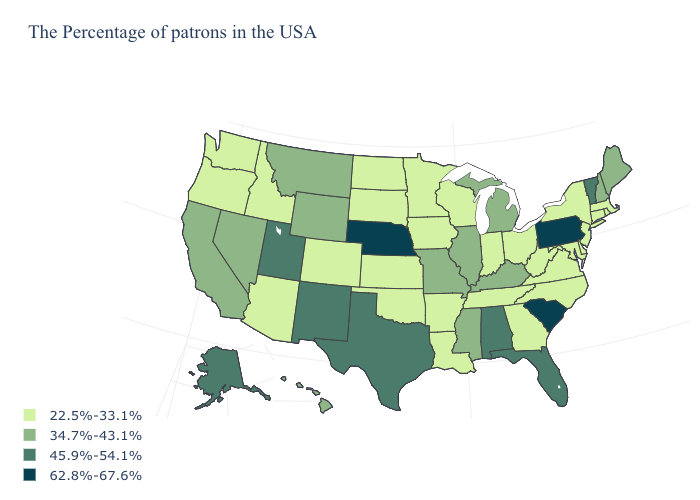Does Vermont have a higher value than Florida?
Keep it brief. No. Name the states that have a value in the range 22.5%-33.1%?
Keep it brief. Massachusetts, Rhode Island, Connecticut, New York, New Jersey, Delaware, Maryland, Virginia, North Carolina, West Virginia, Ohio, Georgia, Indiana, Tennessee, Wisconsin, Louisiana, Arkansas, Minnesota, Iowa, Kansas, Oklahoma, South Dakota, North Dakota, Colorado, Arizona, Idaho, Washington, Oregon. What is the lowest value in the West?
Short answer required. 22.5%-33.1%. What is the value of Iowa?
Concise answer only. 22.5%-33.1%. Is the legend a continuous bar?
Give a very brief answer. No. Name the states that have a value in the range 45.9%-54.1%?
Write a very short answer. Vermont, Florida, Alabama, Texas, New Mexico, Utah, Alaska. Name the states that have a value in the range 22.5%-33.1%?
Give a very brief answer. Massachusetts, Rhode Island, Connecticut, New York, New Jersey, Delaware, Maryland, Virginia, North Carolina, West Virginia, Ohio, Georgia, Indiana, Tennessee, Wisconsin, Louisiana, Arkansas, Minnesota, Iowa, Kansas, Oklahoma, South Dakota, North Dakota, Colorado, Arizona, Idaho, Washington, Oregon. Name the states that have a value in the range 22.5%-33.1%?
Give a very brief answer. Massachusetts, Rhode Island, Connecticut, New York, New Jersey, Delaware, Maryland, Virginia, North Carolina, West Virginia, Ohio, Georgia, Indiana, Tennessee, Wisconsin, Louisiana, Arkansas, Minnesota, Iowa, Kansas, Oklahoma, South Dakota, North Dakota, Colorado, Arizona, Idaho, Washington, Oregon. Does Alaska have the lowest value in the USA?
Keep it brief. No. What is the highest value in the USA?
Short answer required. 62.8%-67.6%. Does the map have missing data?
Quick response, please. No. Does New Jersey have the lowest value in the USA?
Concise answer only. Yes. What is the lowest value in states that border Connecticut?
Concise answer only. 22.5%-33.1%. Does Massachusetts have the lowest value in the Northeast?
Short answer required. Yes. What is the value of Ohio?
Concise answer only. 22.5%-33.1%. 